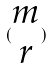<formula> <loc_0><loc_0><loc_500><loc_500>( \begin{matrix} m \\ r \end{matrix} )</formula> 